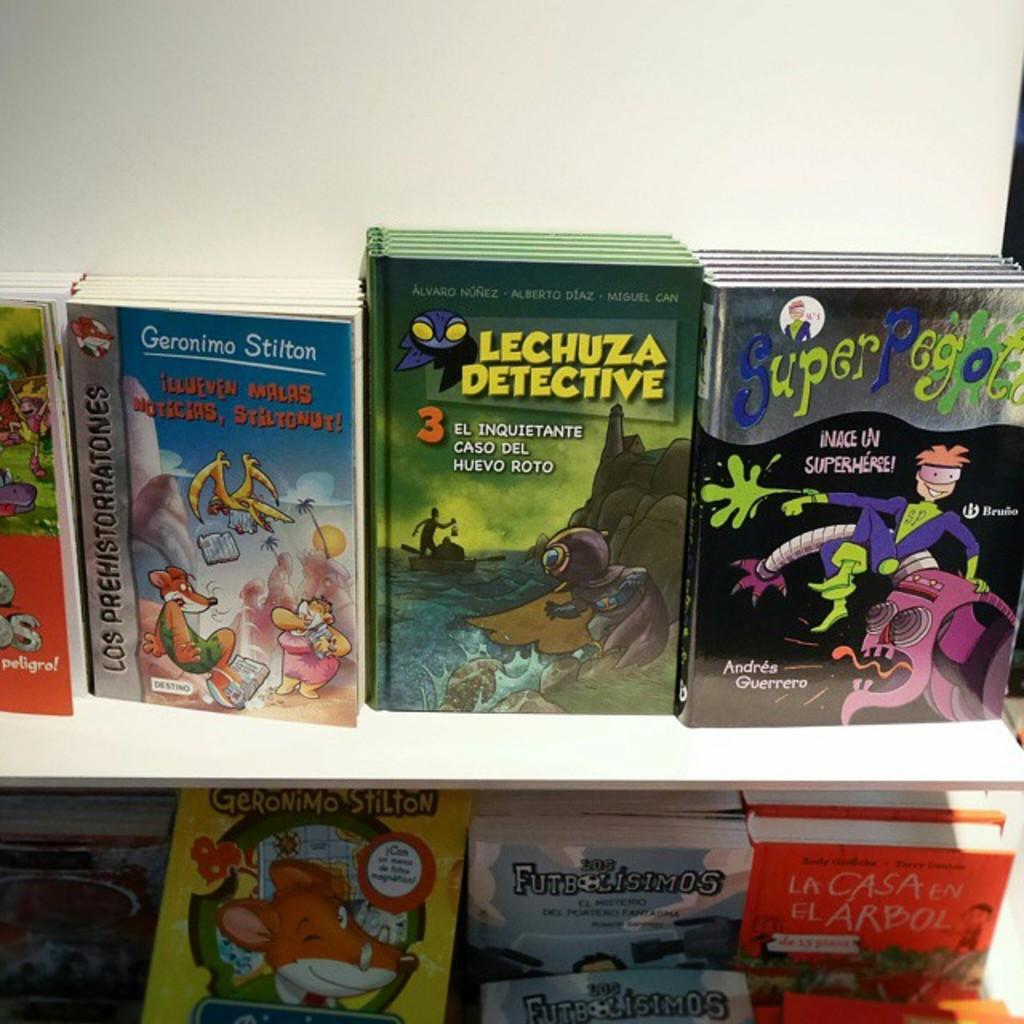What language are the books printed in?
Provide a succinct answer. Spanish. What is the title of the middle book?
Keep it short and to the point. Lechuza detective. 